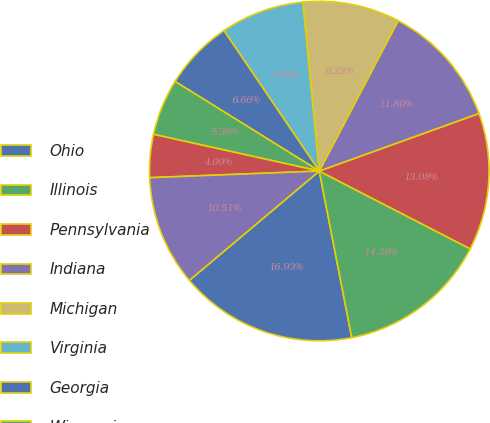<chart> <loc_0><loc_0><loc_500><loc_500><pie_chart><fcel>Ohio<fcel>Illinois<fcel>Pennsylvania<fcel>Indiana<fcel>Michigan<fcel>Virginia<fcel>Georgia<fcel>Wisconsin<fcel>Tennessee<fcel>North Carolina<nl><fcel>16.93%<fcel>14.36%<fcel>13.08%<fcel>11.8%<fcel>9.23%<fcel>7.95%<fcel>6.66%<fcel>5.38%<fcel>4.09%<fcel>10.51%<nl></chart> 